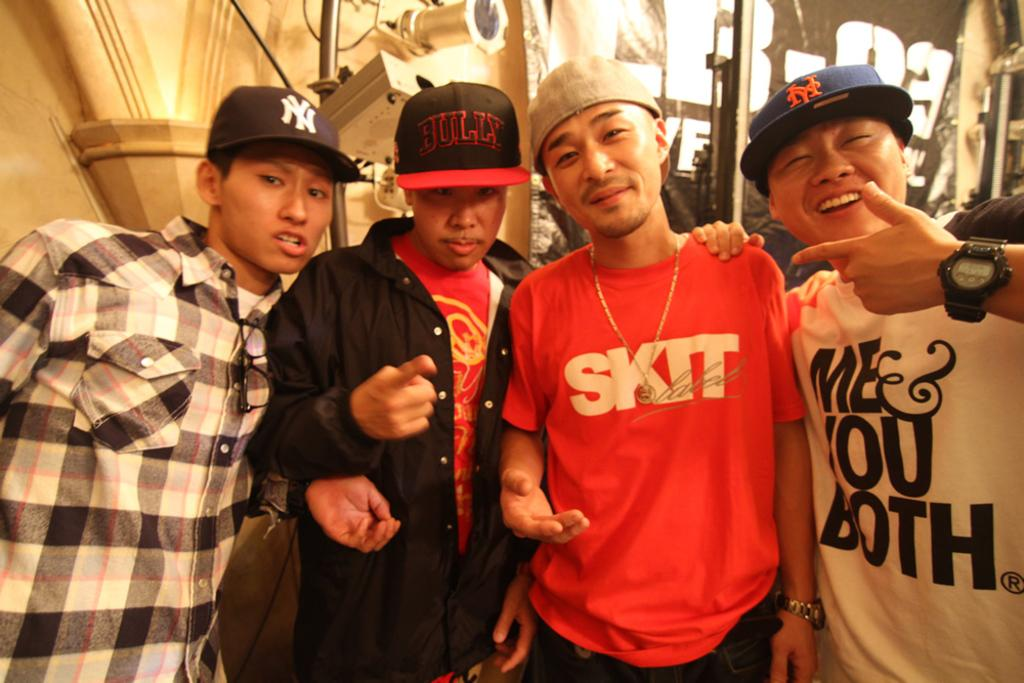What is happening in the center of the image? There are persons standing in the center of the image. What are the persons wearing on their heads? The persons are wearing caps. What can be seen in the background of the image? There is a wall in the background of the image. What book is the father reading to the children in the image? There is no father or children present in the image, and no book is visible. 